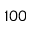<formula> <loc_0><loc_0><loc_500><loc_500>1 0 0</formula> 